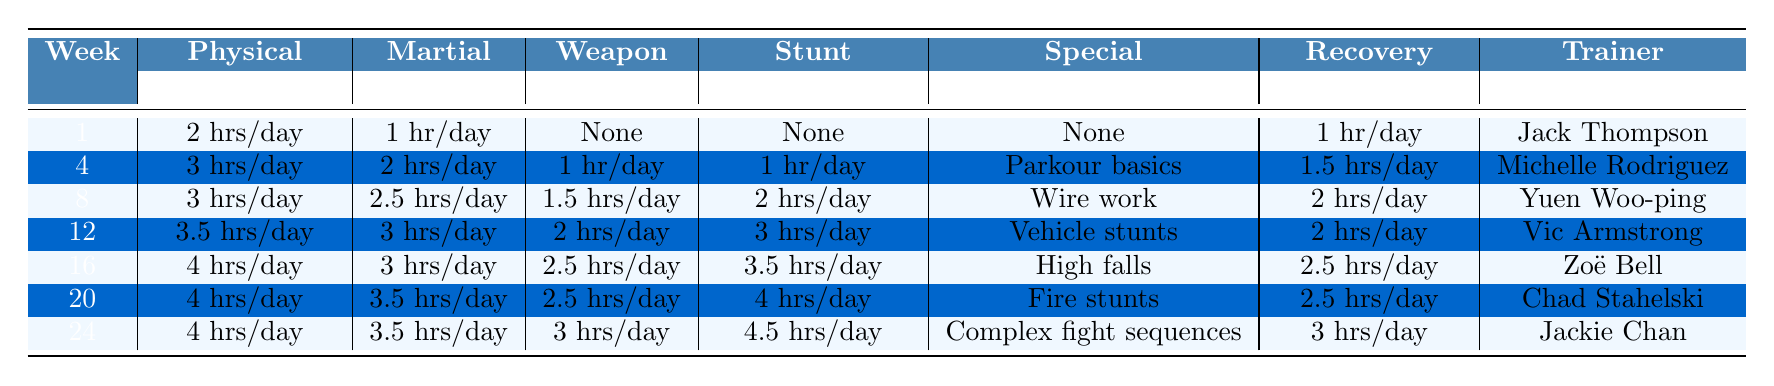What is the total number of hours dedicated to Physical Conditioning in Week 12? The entry for Week 12 shows Physical Conditioning being 3.5 hours/day. Since it is a single week, the total (3.5 hours) is simply the value listed.
Answer: 3.5 hours/day Which trainer is assigned in Week 16? The table lists Zoë Bell as the trainer for Week 16.
Answer: Zoë Bell In Week 20, what special skills are being focused on? The table indicates that the special skills focused on in Week 20 are Fire stunts.
Answer: Fire stunts What is the average daily time spent on Recovery and Therapy across all weeks? Summing the Recovery and Therapy hours: (1 + 1.5 + 2 + 2 + 2.5 + 2.5 + 3) hours = 14.5 hours. Dividing this by the number of weeks (7) gives an average of approximately 2.07 hours.
Answer: 2.07 hours/day How many hours are spent on Stunt Choreography during Week 24? For Week 24, the table shows that 4.5 hours/day are allocated to Stunt Choreography.
Answer: 4.5 hours/day Is there any week where no Weapon Training is scheduled, and if so, which week? The table shows that Week 1 has "None" listed for Weapon Training, indicating that no Weapon Training is scheduled during that week.
Answer: Yes, Week 1 What is the increase in hours of Physical Conditioning from Week 4 to Week 16? Physical Conditioning hours for Week 4 is 3 hours/day, and for Week 16 it is 4 hours/day. The increase is 4 - 3 = 1 hour/day.
Answer: 1 hour/day Considering the entire training schedule, which week has the most total hours across all training categories? Calculating total hours for each week: Week 1 = 3, Week 4 = 8.5, Week 8 = 9.5, Week 12 = 11.5, Week 16 = 13.5, Week 20 = 15.5, Week 24 = 17.5. Week 24 has the most total hours, which is 17.5 hours.
Answer: Week 24 What is the trend in Weapon Training hours over the weeks? Reviewing the Weapon Training hours: Week 1 (None), Week 4 (1 hr/day), Week 8 (1.5 hrs/day), Week 12 (2 hrs/day), Week 16 (2.5 hrs/day), Week 20 (2.5 hrs/day), Week 24 (3 hrs/day). The trend shows a consistent increase, peaking at Week 24.
Answer: Consistent increase In Weeks 8 and 20, what is the difference in Martial Arts training hours? Week 8 has 2.5 hours/day for Martial Arts, and Week 20 has 3.5 hours/day. The difference is 3.5 - 2.5 = 1 hour.
Answer: 1 hour 